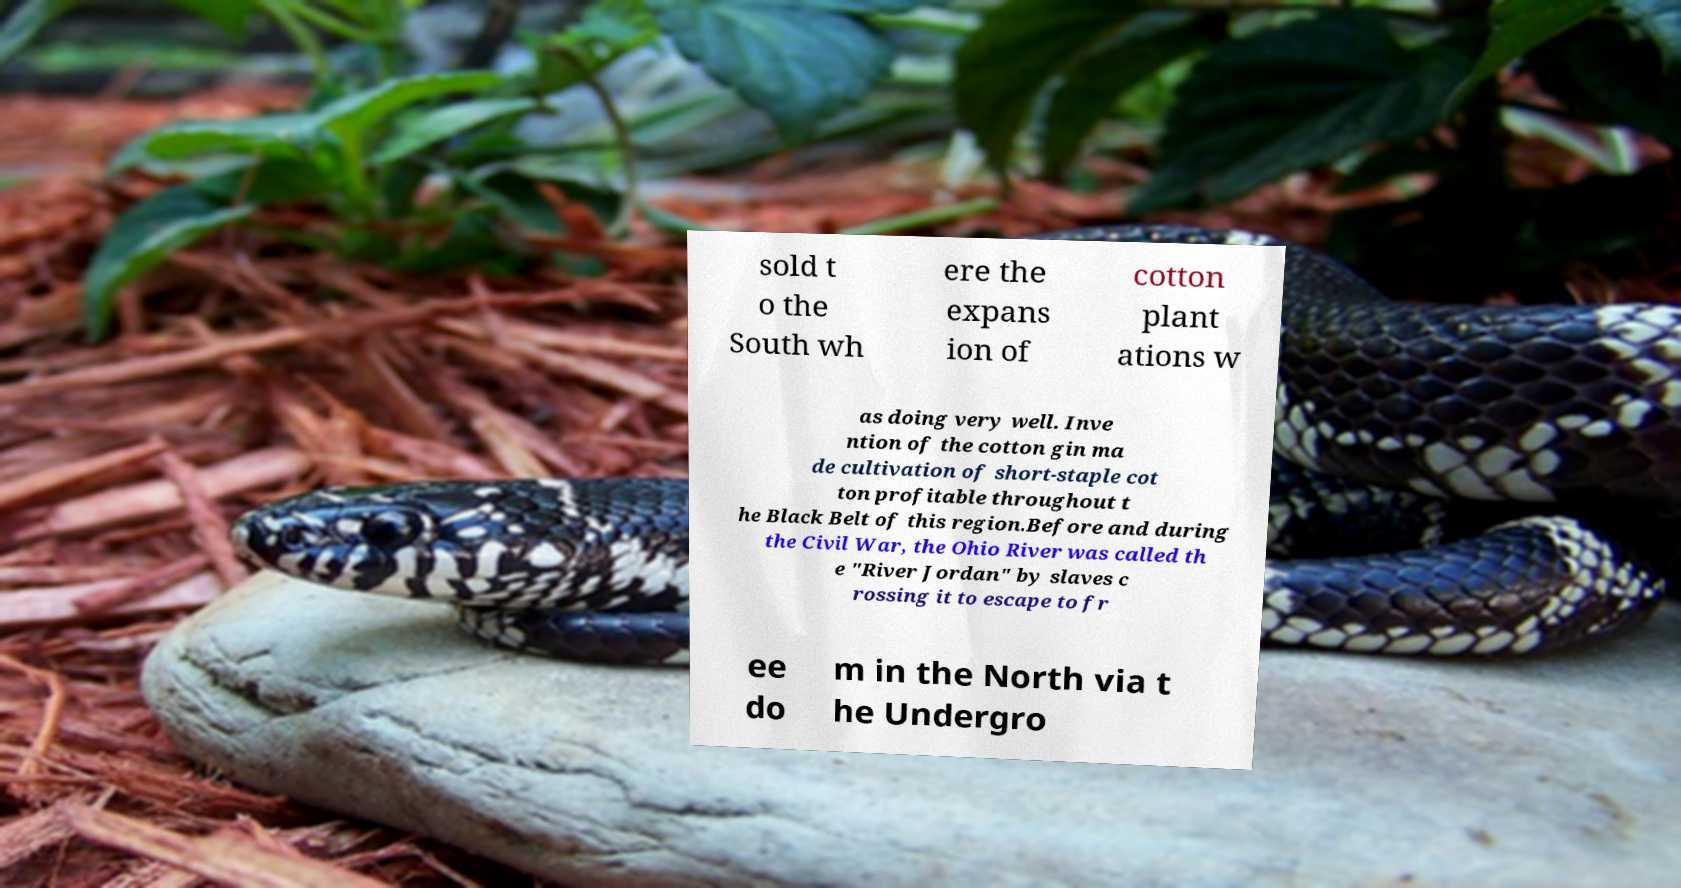Please identify and transcribe the text found in this image. sold t o the South wh ere the expans ion of cotton plant ations w as doing very well. Inve ntion of the cotton gin ma de cultivation of short-staple cot ton profitable throughout t he Black Belt of this region.Before and during the Civil War, the Ohio River was called th e "River Jordan" by slaves c rossing it to escape to fr ee do m in the North via t he Undergro 